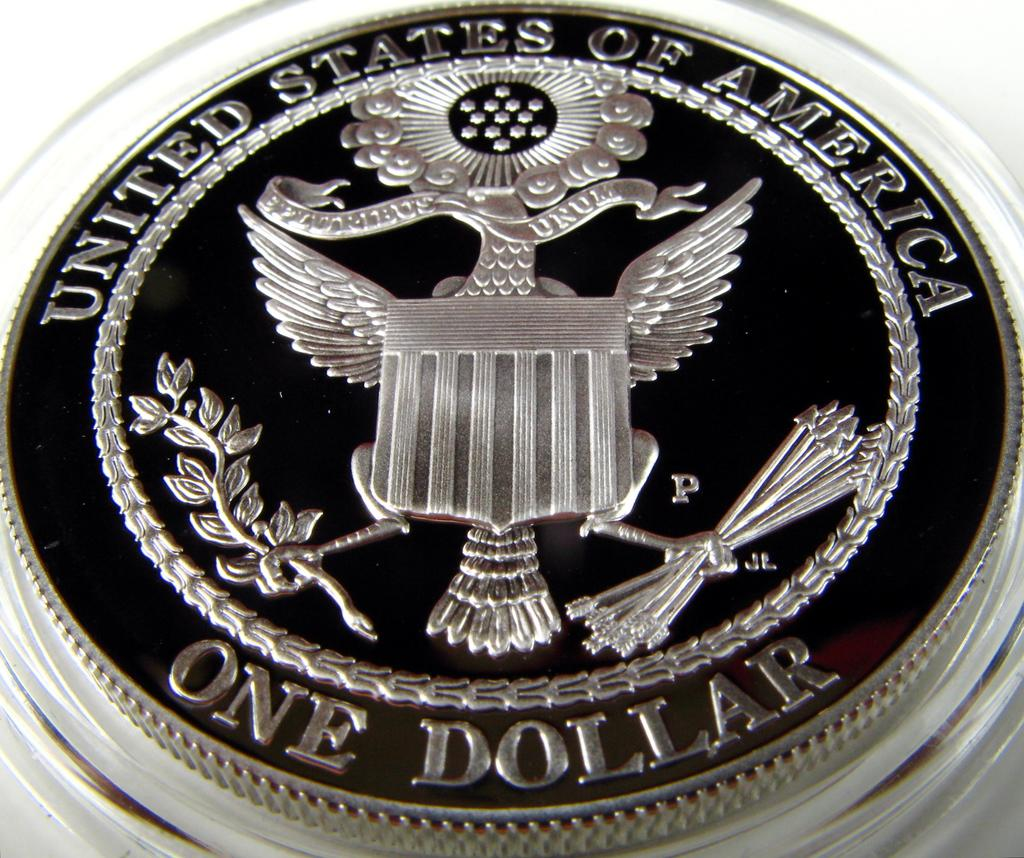<image>
Write a terse but informative summary of the picture. A beautiful Silver United States one dollar coin. 